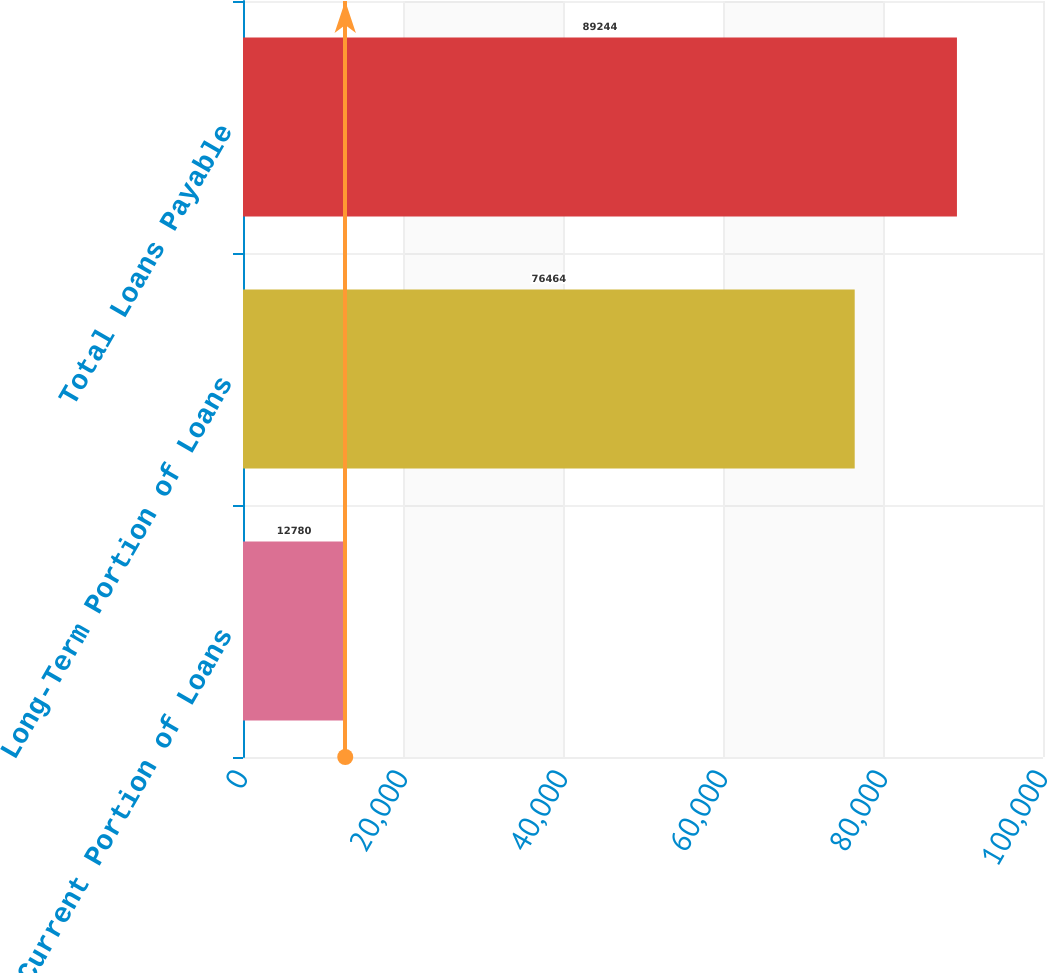<chart> <loc_0><loc_0><loc_500><loc_500><bar_chart><fcel>Current Portion of Loans<fcel>Long-Term Portion of Loans<fcel>Total Loans Payable<nl><fcel>12780<fcel>76464<fcel>89244<nl></chart> 